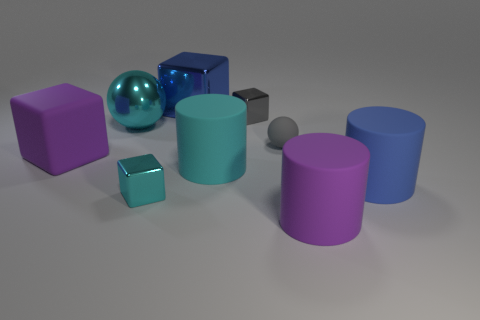The other small object that is the same color as the small rubber thing is what shape?
Provide a succinct answer. Cube. How many metal balls are the same size as the blue rubber cylinder?
Keep it short and to the point. 1. There is a tiny ball that is behind the blue matte cylinder; are there any gray blocks that are behind it?
Ensure brevity in your answer.  Yes. How many things are cyan blocks or tiny gray shiny blocks?
Offer a very short reply. 2. The ball on the right side of the tiny metallic cube that is to the right of the blue object behind the large blue matte cylinder is what color?
Provide a short and direct response. Gray. Do the cyan shiny sphere and the gray ball have the same size?
Your response must be concise. No. What number of objects are large matte objects that are behind the purple cylinder or metal blocks to the left of the tiny gray metallic block?
Provide a short and direct response. 5. What material is the tiny thing behind the cyan metallic thing behind the gray rubber ball?
Offer a terse response. Metal. How many other things are there of the same material as the big blue cylinder?
Give a very brief answer. 4. Is the shape of the big blue metal thing the same as the small gray metal thing?
Make the answer very short. Yes. 